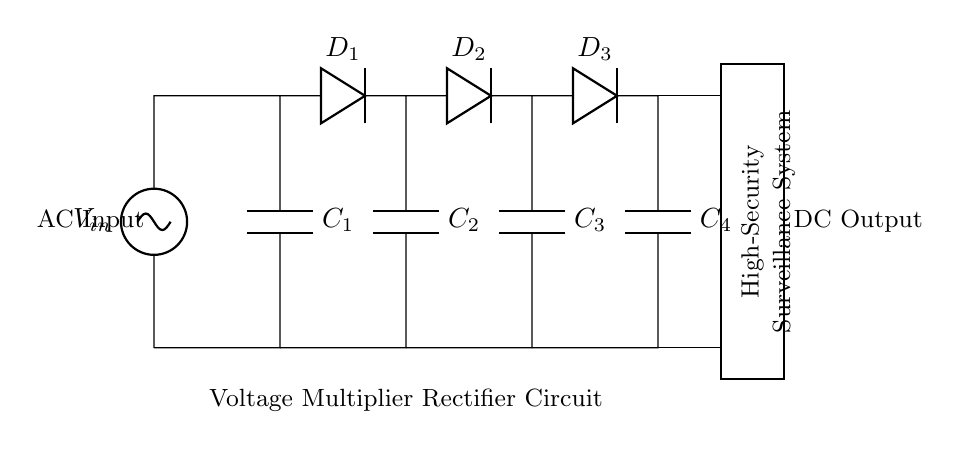What is the main function of this circuit? The main function of this circuit is to convert AC input voltage into a higher DC output voltage using capacitors and diodes for voltage multiplication.
Answer: Voltage multiplication How many capacitors are in the circuit? By visually inspecting the diagram, there are four capacitors labeled C1, C2, C3, and C4 present in the circuit.
Answer: Four What is the role of the diodes in this circuit? The diodes (D1, D2, D3) are used for rectification, allowing current to flow in one direction and thus converting the AC input into pulsed DC output while preventing backflow.
Answer: Rectification What type of current does the circuit output? The circuit outputs direct current (DC) as indicated by the configuration of components that convert alternating current (AC) input.
Answer: Direct current What is the voltage multiplication factor theoretically achieved if all capacitors and diodes function perfectly? For a voltage multiplier rectifier with four capacitors, the theoretical multiplication factor is fourfold, effectively boosting the input voltage by this factor.
Answer: Fourfold What component provides the AC input in this circuit? The circuit diagram clearly indicates that V_in represents the AC voltage source, providing the necessary input for the rectifier function.
Answer: AC Voltage source 